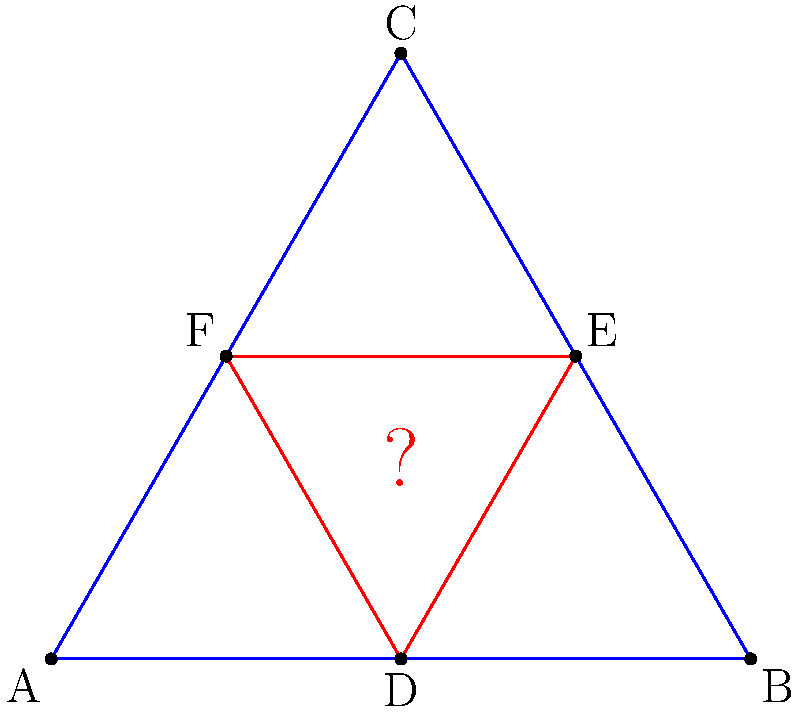In the enigmatic symbol above, two equilateral triangles are intertwined. Triangle ABC (blue) has side length 2, while the red triangle DEF is inscribed within it. If these triangles are congruent, what is the length of side DE in the red triangle? Express your answer in simplest radical form. Let's unravel this mystery step by step:

1) First, recognize that triangle ABC is equilateral with side length 2.

2) The red triangle DEF is inscribed in ABC, with its vertices at the midpoints of ABC's sides.

3) To prove congruence, we need to show that DEF is also equilateral and find its side length.

4) In an equilateral triangle, the distance from any vertex to the midpoint of the opposite side is $\frac{\sqrt{3}}{2}$ times the side length.

5) So, the height of triangle ABC is:
   $h = 2 \cdot \frac{\sqrt{3}}{2} = \sqrt{3}$

6) Now, let's focus on triangle ADF (half of the red triangle):
   - AD is half of AB, so $AD = 1$
   - The height of ADF is $\frac{\sqrt{3}}{2}$ (half the height of ABC)

7) Using the Pythagorean theorem in ADF:
   $DF^2 = AD^2 + (\frac{\sqrt{3}}{2})^2$
   $DF^2 = 1^2 + (\frac{\sqrt{3}}{2})^2 = 1 + \frac{3}{4} = \frac{7}{4}$

8) Therefore, $DF = \frac{\sqrt{7}}{2}$

9) Since DEF is equilateral, all its sides have length $\frac{\sqrt{7}}{2}$

Thus, we've proven that DEF is equilateral and found its side length, confirming the congruence of the two triangles.
Answer: $\frac{\sqrt{7}}{2}$ 